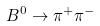<formula> <loc_0><loc_0><loc_500><loc_500>B ^ { 0 } \rightarrow \pi ^ { + } \pi ^ { - }</formula> 